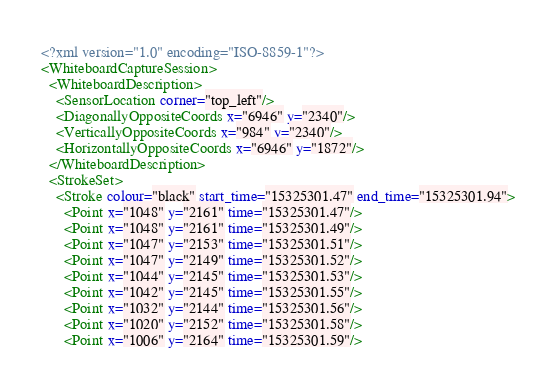<code> <loc_0><loc_0><loc_500><loc_500><_XML_><?xml version="1.0" encoding="ISO-8859-1"?>
<WhiteboardCaptureSession>
  <WhiteboardDescription>
    <SensorLocation corner="top_left"/>
    <DiagonallyOppositeCoords x="6946" y="2340"/>
    <VerticallyOppositeCoords x="984" y="2340"/>
    <HorizontallyOppositeCoords x="6946" y="1872"/>
  </WhiteboardDescription>
  <StrokeSet>
    <Stroke colour="black" start_time="15325301.47" end_time="15325301.94">
      <Point x="1048" y="2161" time="15325301.47"/>
      <Point x="1048" y="2161" time="15325301.49"/>
      <Point x="1047" y="2153" time="15325301.51"/>
      <Point x="1047" y="2149" time="15325301.52"/>
      <Point x="1044" y="2145" time="15325301.53"/>
      <Point x="1042" y="2145" time="15325301.55"/>
      <Point x="1032" y="2144" time="15325301.56"/>
      <Point x="1020" y="2152" time="15325301.58"/>
      <Point x="1006" y="2164" time="15325301.59"/></code> 